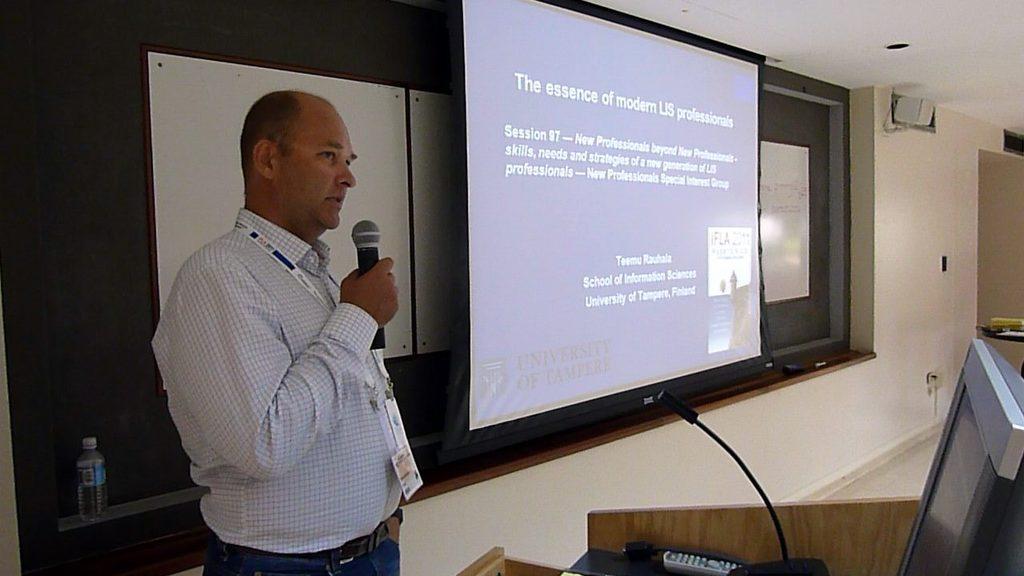Please provide a concise description of this image. In this image we can see a man wearing the identity card and holding the mike and standing. We can also see the monitor, remote, water bottle, boards, wall, door and also the display screen with the text. We can also see the ceiling and also the floor. 